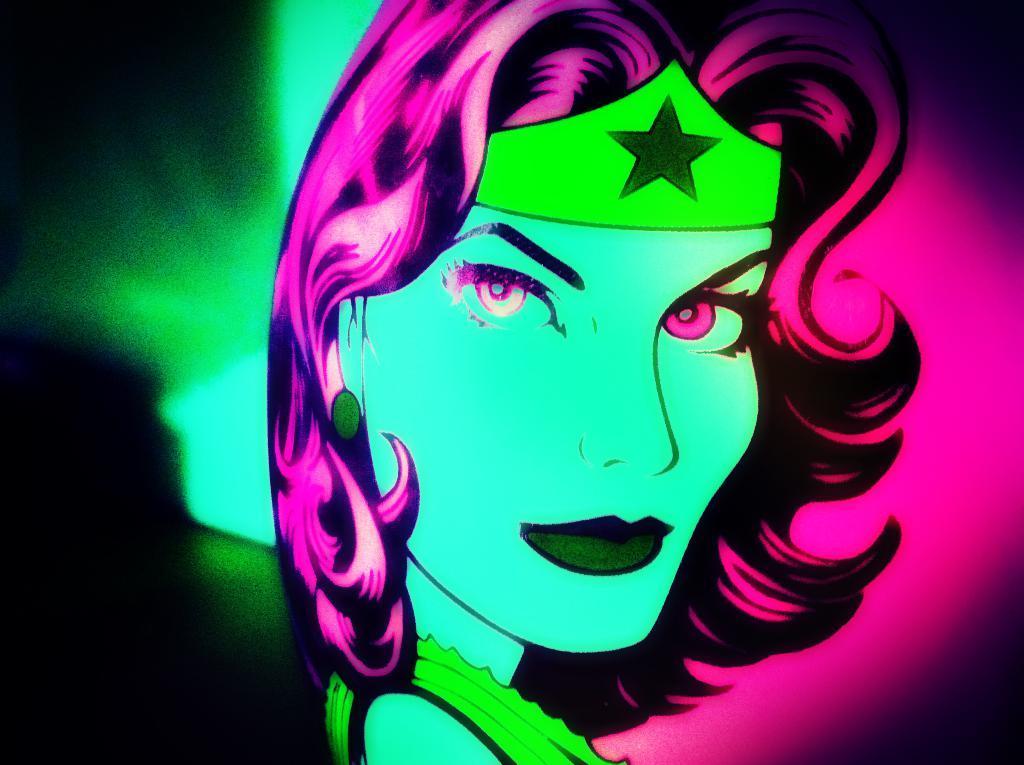In one or two sentences, can you explain what this image depicts? It is the digital art of a woman. 